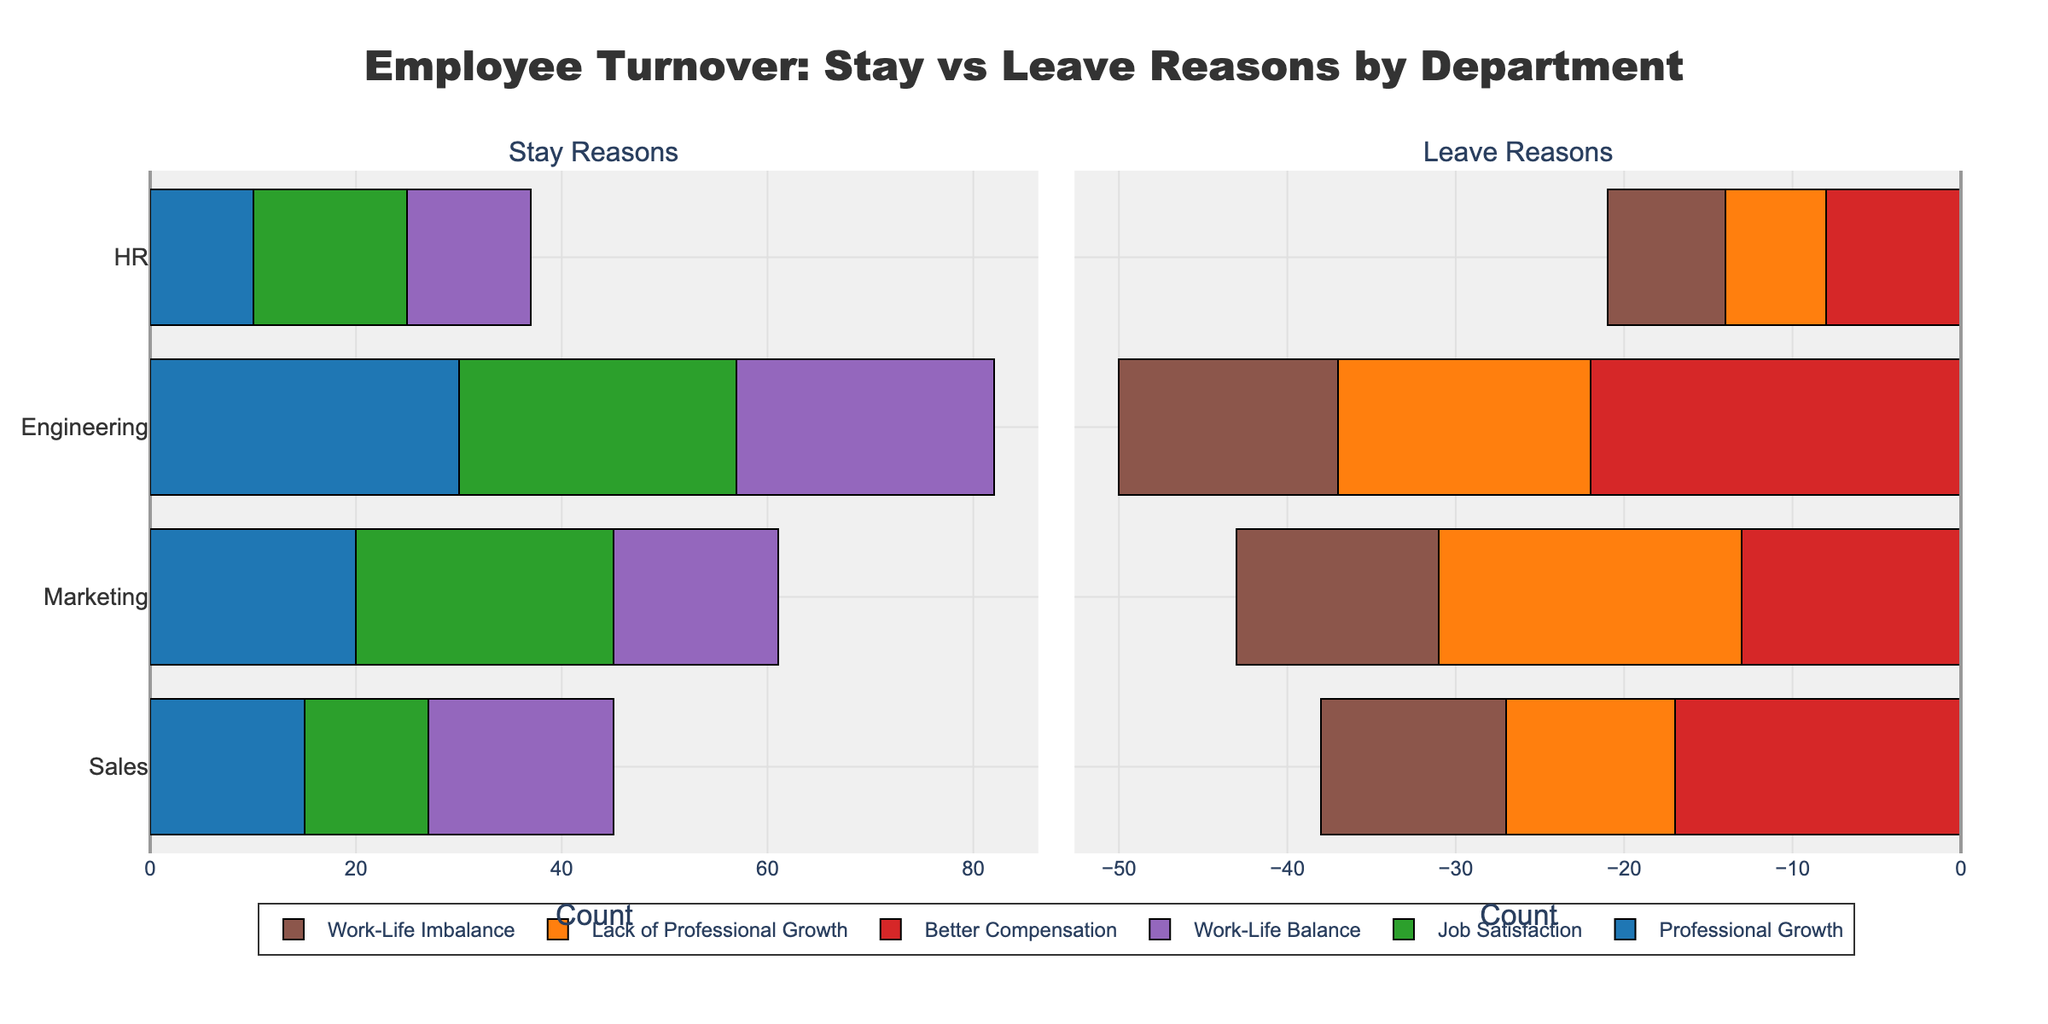How many total employees are leaving the Sales department? Add the lengths of all bars in the Leave Reasons subplot for Sales (17 + 10 + 11).
Answer: 38 In which department is Work-Life Balance the most cited reason for staying? Compare the lengths of the bars for Work-Life Balance in the Stay Reasons subplot across all departments; Engineering has the longest bar.
Answer: Engineering Is the number of employees staying for Professional Growth greater than those leaving for Lack of Professional Growth in the HR department? Compare the lengths of the bars for Professional Growth in Stay Reasons and Lack of Professional Growth in Leave Reasons for HR. The bar for Professional Growth is longer (10 vs. 6).
Answer: Yes How many departments have more employees leaving due to Better Compensation than those staying for Professional Growth? Compare the lengths of Better Compensation bars in Leave Reasons and Professional Growth in Stay Reasons for each department: Sales (Yes), Marketing (No), Engineering (No), HR (No). Only Sales meets the criteria.
Answer: 1 In which department are the total reasons for leaving greater than the total reasons for staying? Compare the sum of all bars for Stay Reasons and Leave Reasons for each department. Sales: 45 (Stay) vs 38 (Leave), Marketing: 61 (Stay) vs 43 (Leave), Engineering: 82 (Stay) vs 50 (Leave), HR: 37 (Stay) vs 21 (Leave). None have more leaving than staying.
Answer: None 